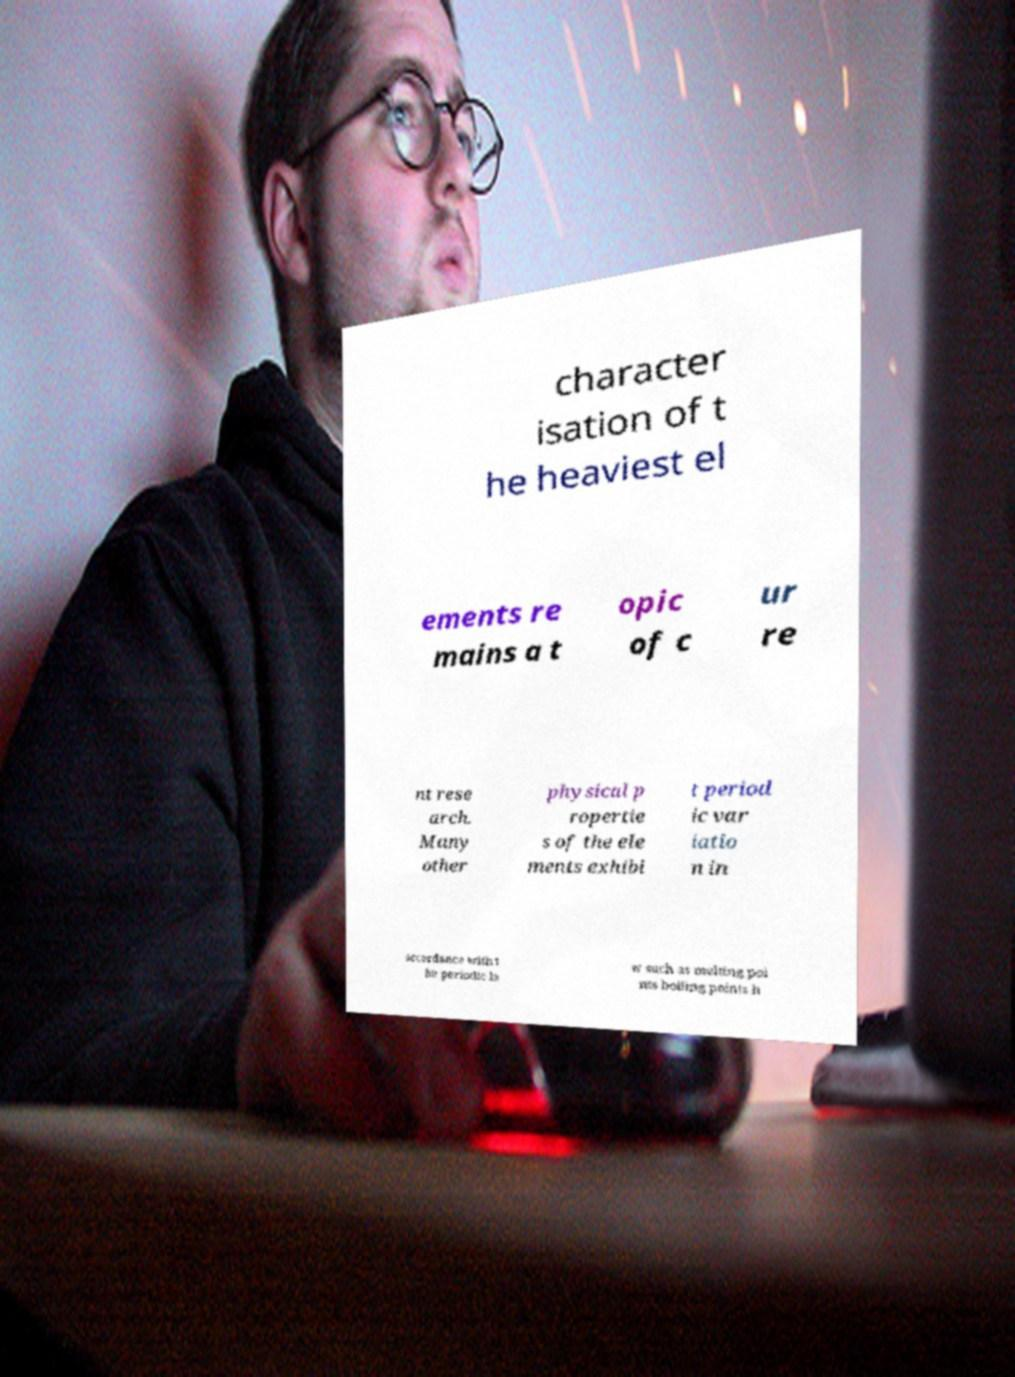For documentation purposes, I need the text within this image transcribed. Could you provide that? character isation of t he heaviest el ements re mains a t opic of c ur re nt rese arch. Many other physical p ropertie s of the ele ments exhibi t period ic var iatio n in accordance with t he periodic la w such as melting poi nts boiling points h 